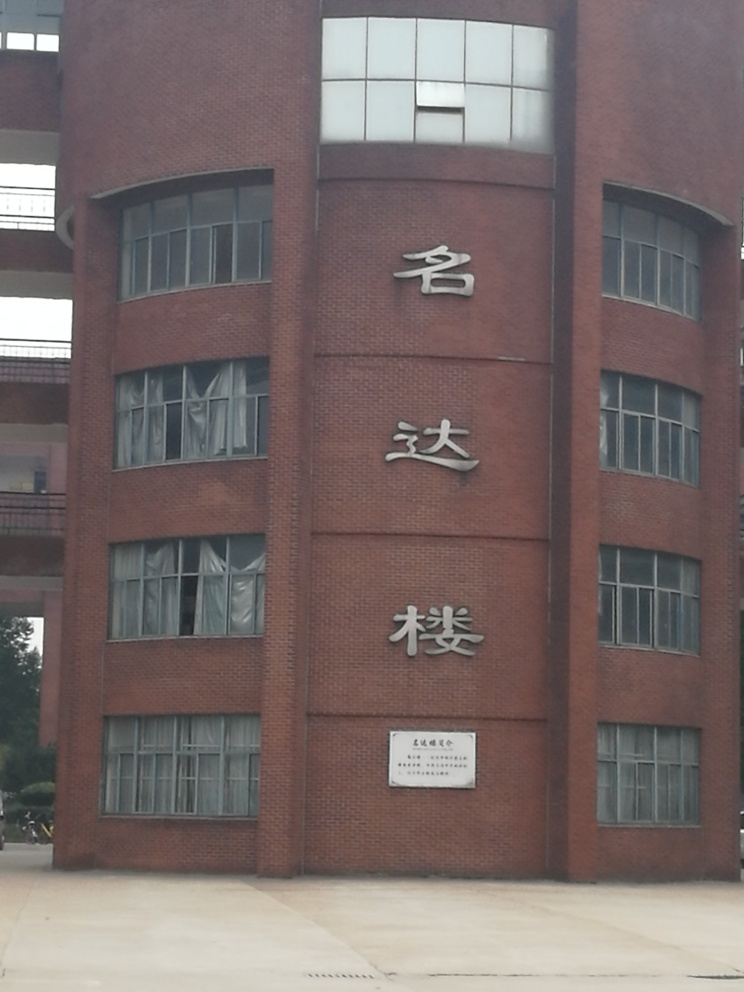How does the subject '达楼' appear in the image?
A. perfectly focused
B. clear and well-composed
C. slightly blurry and poorly composed
Answer with the option's letter from the given choices directly. The subject '达楼' in the image is C, slightly blurry and poorly composed. This is evident because the edges of the building and the characters are not sharp, and the overall image has a soft focus, which reduces the clarity typically seen in well-composed photography. Additionally, the composition could be improved by adjusting the perspective to avoid the slight tilt visible in the photo. 